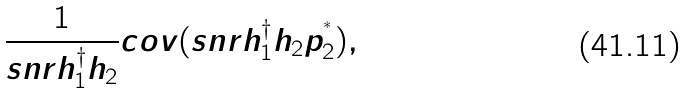Convert formula to latex. <formula><loc_0><loc_0><loc_500><loc_500>\frac { 1 } { s n r { h _ { 1 } ^ { \dag } } { { h } _ { 2 } } } c o v ( s n r h _ { 1 } ^ { \dag } { { h } _ { 2 } } p _ { 2 } ^ { ^ { * } } ) ,</formula> 